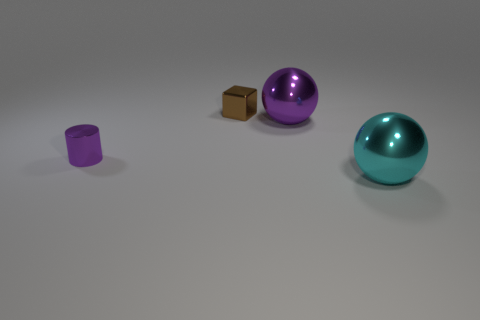Add 1 shiny cylinders. How many objects exist? 5 Subtract 1 cylinders. How many cylinders are left? 0 Add 4 cyan spheres. How many cyan spheres are left? 5 Add 2 big cyan matte blocks. How many big cyan matte blocks exist? 2 Subtract 1 brown cubes. How many objects are left? 3 Subtract all red cylinders. Subtract all brown spheres. How many cylinders are left? 1 Subtract all green cylinders. How many purple spheres are left? 1 Subtract all small brown objects. Subtract all small purple metallic cylinders. How many objects are left? 2 